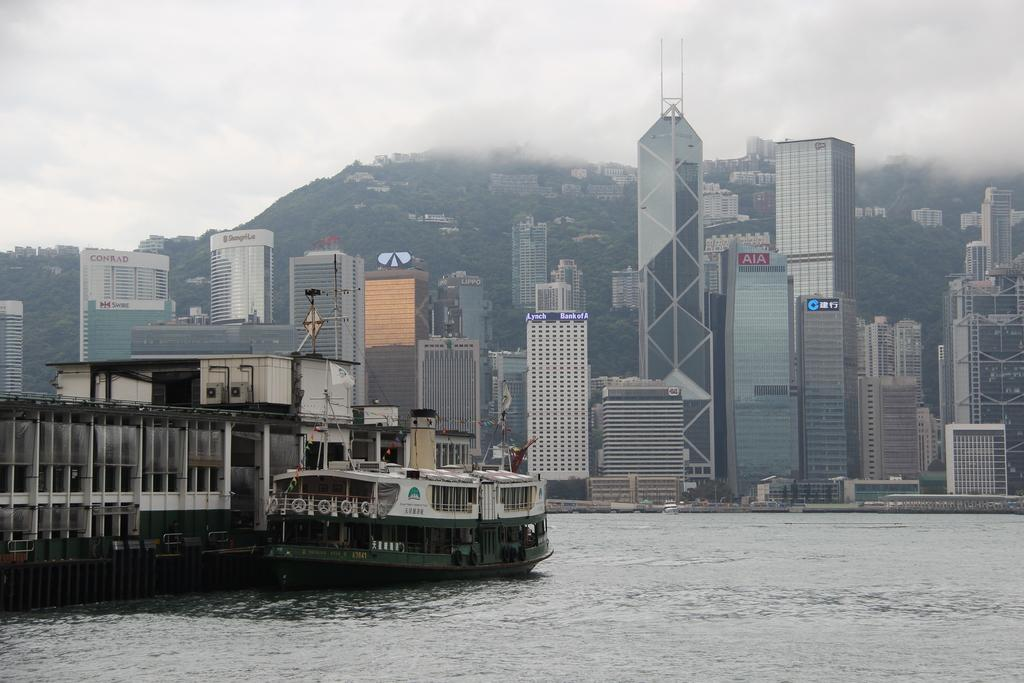What type of structures can be seen in the image? There are buildings in the image. What other natural elements are present in the image? There are trees in the image. What is located in the water in the image? There is a ship in the water in the image. How would you describe the sky in the image? The sky is cloudy in the image. Can you see any worms crawling on the grass in the image? There is no grass present in the image, and therefore no worms can be seen. 